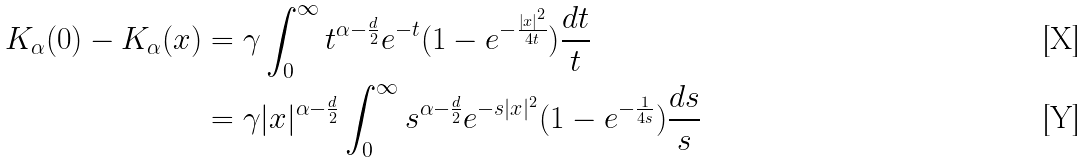Convert formula to latex. <formula><loc_0><loc_0><loc_500><loc_500>K _ { \alpha } ( 0 ) - K _ { \alpha } ( x ) & = \gamma \int _ { 0 } ^ { \infty } t ^ { \alpha - \frac { d } { 2 } } e ^ { - t } ( 1 - e ^ { - \frac { \left | x \right | ^ { 2 } } { 4 t } } ) \frac { d t } { t } \\ & = \gamma | x | ^ { \alpha - \frac { d } { 2 } } \int _ { 0 } ^ { \infty } s ^ { \alpha - \frac { d } { 2 } } e ^ { - s | x | ^ { 2 } } ( 1 - e ^ { - \frac { 1 } { 4 s } } ) \frac { d s } { s }</formula> 